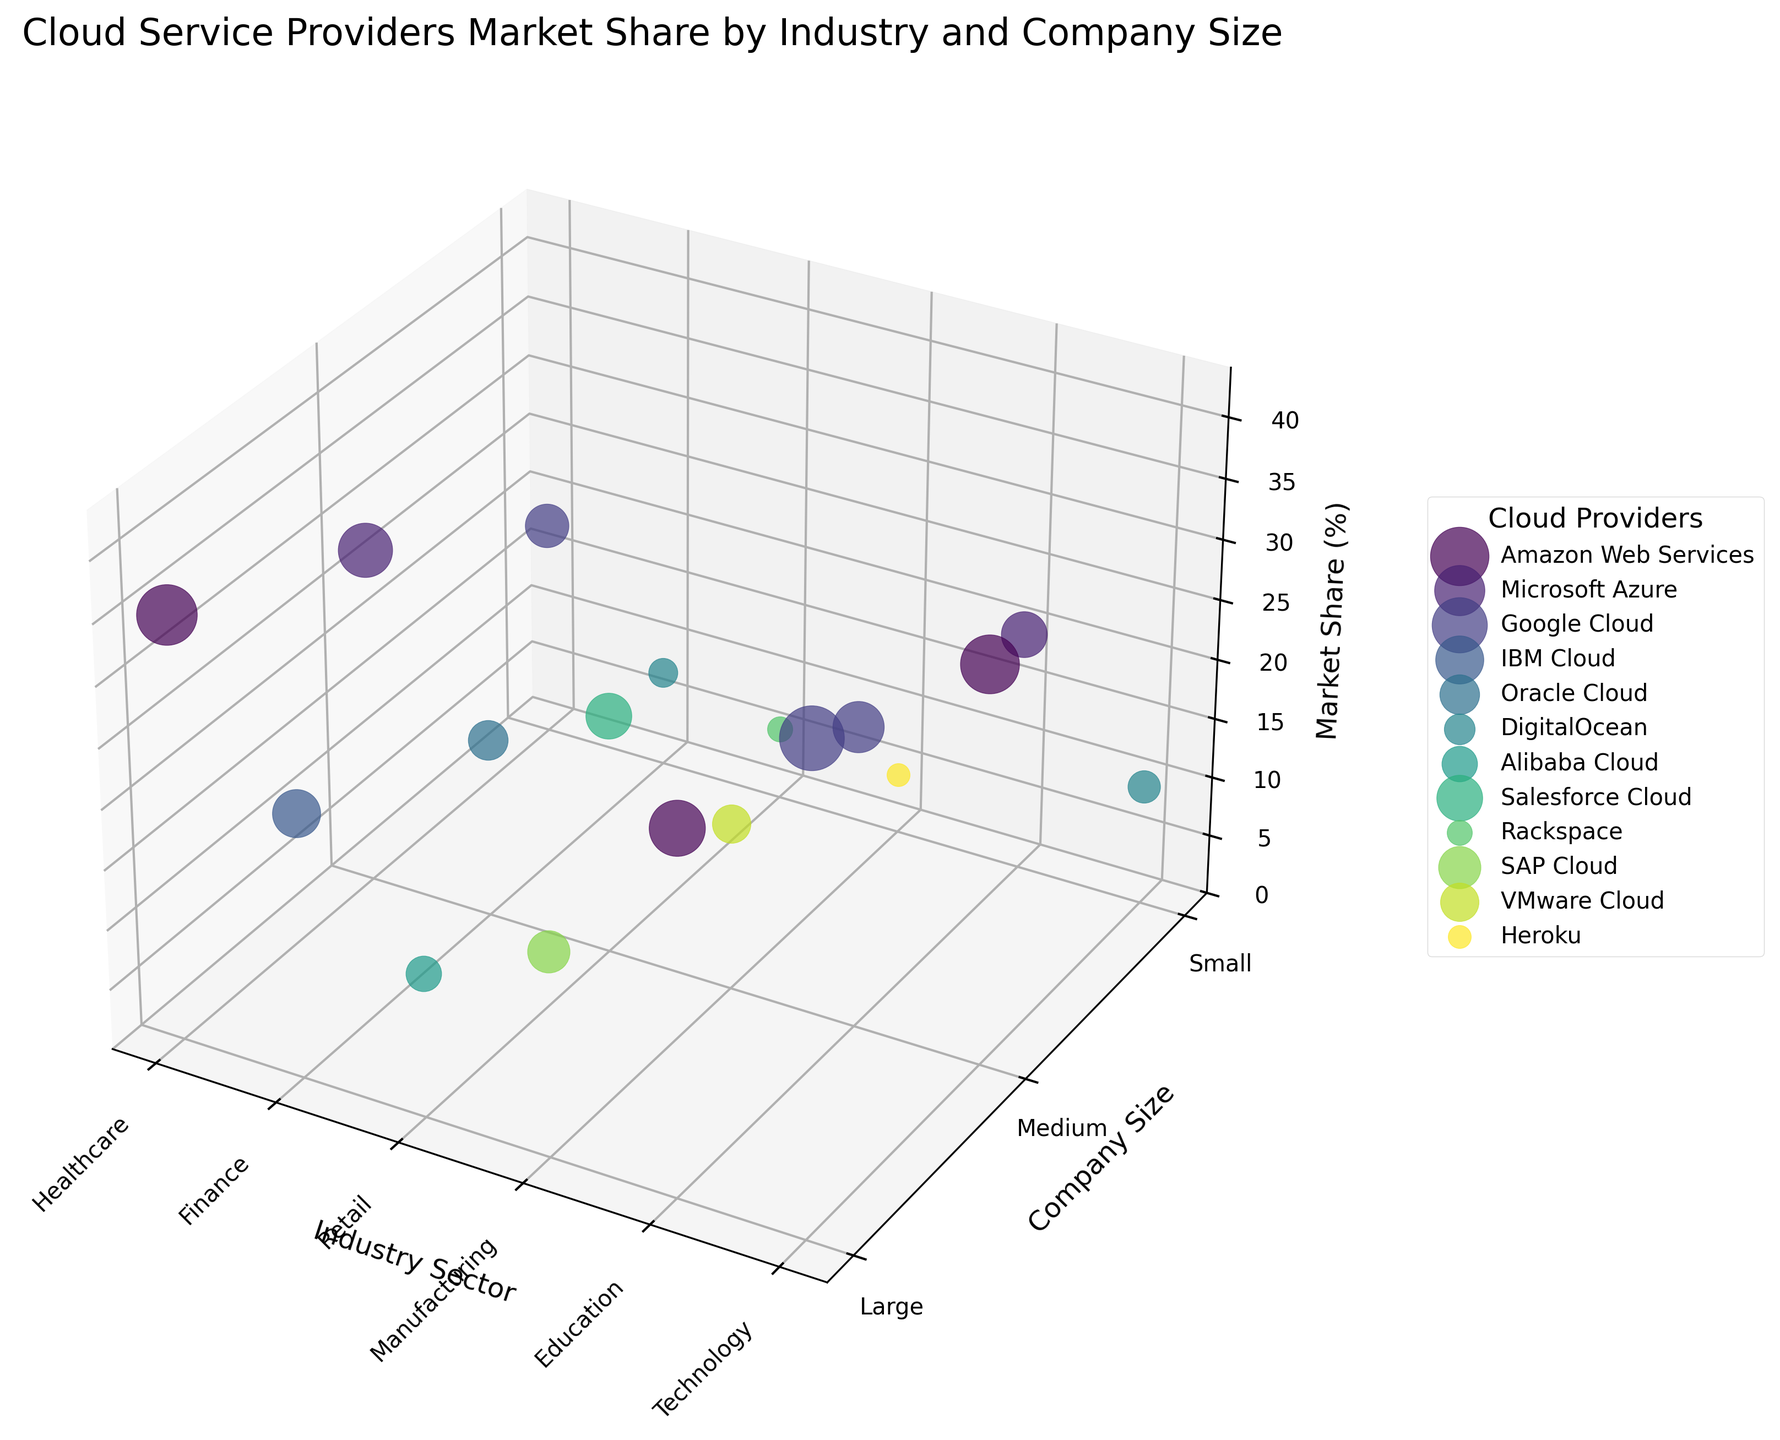What is the title of the figure? The title of the figure is displayed at the top of the plot.
Answer: Cloud Service Providers Market Share by Industry and Company Size Which cloud provider has the highest market share in the technology industry for large companies? To find this, we look for the "Technology" sector and "Large" company size. The largest bubble in this region represents Google Cloud.
Answer: Google Cloud What is the range of the Z-axis? The Z-axis represents market share and is set from 0 to slightly above the maximum market share, which is 40%.
Answer: 0 to 44 How does the market share for Amazon Web Services compare between large companies in the healthcare and technology sectors? For large companies in the healthcare sector, AWS market share is 35%. In the technology sector, it doesn’t appear as AWS isn’t represented by a bubble in this sector for large companies.
Answer: Higher in healthcare; absent in technology In the education sector, which cloud provider has the smallest market share for small companies? In the small companies category within the education sector, the smallest market share is represented by Microsoft Azure.
Answer: Microsoft Azure How many cloud providers are included in the figure? Each unique color represents a different cloud provider. Counting the colors or labels in the legend reveals there are 12 cloud providers.
Answer: 12 In the finance sector, what is the total market share for small companies across all cloud providers? Summing up the market shares for the small companies in finance, we have DigitalOcean with 8%.
Answer: 8% Which company size has the most consistent market share across different industry sectors for Google Cloud? Examining the sizes of Google Cloud bubbles across sectors, medium-sized companies show a fairly consistent presence with market shares of 33% (Technology) and 25% (Education).
Answer: Medium Do smaller companies show a more diverse range of cloud providers compared to large companies? Small companies feature DigitalOcean, Google Cloud, Microsoft Azure, etc., whereas large companies have fewer diverse providers like AWS and Google Cloud consistently present.
Answer: Yes In the retail industry, what is the difference in market share between Salesforce Cloud and Alibaba Cloud for medium-sized companies? Retail medium-sized companies have Salesforce Cloud at 20% and Alibaba Cloud not represented for medium-sized companies, hence the difference is 20 - 0 = 20%.
Answer: 20% 